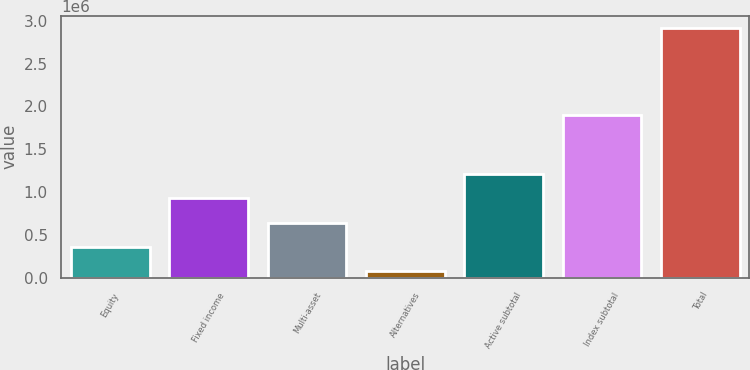Convert chart to OTSL. <chart><loc_0><loc_0><loc_500><loc_500><bar_chart><fcel>Equity<fcel>Fixed income<fcel>Multi-asset<fcel>Alternatives<fcel>Active subtotal<fcel>Index subtotal<fcel>Total<nl><fcel>359219<fcel>926427<fcel>642823<fcel>75615<fcel>1.21003e+06<fcel>1.90168e+06<fcel>2.91166e+06<nl></chart> 